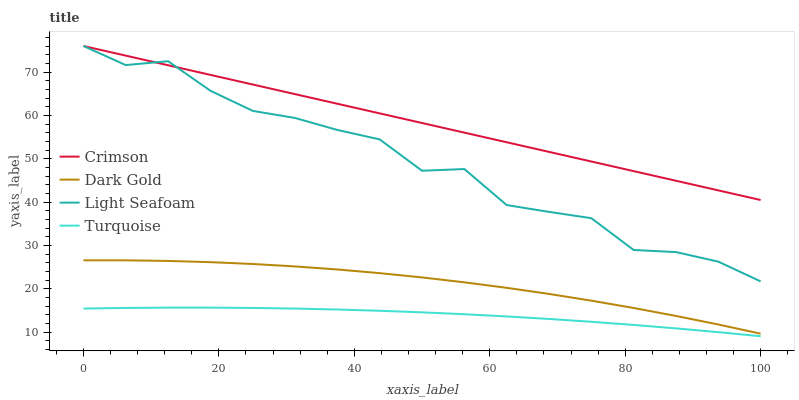Does Turquoise have the minimum area under the curve?
Answer yes or no. Yes. Does Crimson have the maximum area under the curve?
Answer yes or no. Yes. Does Light Seafoam have the minimum area under the curve?
Answer yes or no. No. Does Light Seafoam have the maximum area under the curve?
Answer yes or no. No. Is Crimson the smoothest?
Answer yes or no. Yes. Is Light Seafoam the roughest?
Answer yes or no. Yes. Is Turquoise the smoothest?
Answer yes or no. No. Is Turquoise the roughest?
Answer yes or no. No. Does Turquoise have the lowest value?
Answer yes or no. Yes. Does Light Seafoam have the lowest value?
Answer yes or no. No. Does Light Seafoam have the highest value?
Answer yes or no. Yes. Does Turquoise have the highest value?
Answer yes or no. No. Is Dark Gold less than Light Seafoam?
Answer yes or no. Yes. Is Dark Gold greater than Turquoise?
Answer yes or no. Yes. Does Light Seafoam intersect Crimson?
Answer yes or no. Yes. Is Light Seafoam less than Crimson?
Answer yes or no. No. Is Light Seafoam greater than Crimson?
Answer yes or no. No. Does Dark Gold intersect Light Seafoam?
Answer yes or no. No. 